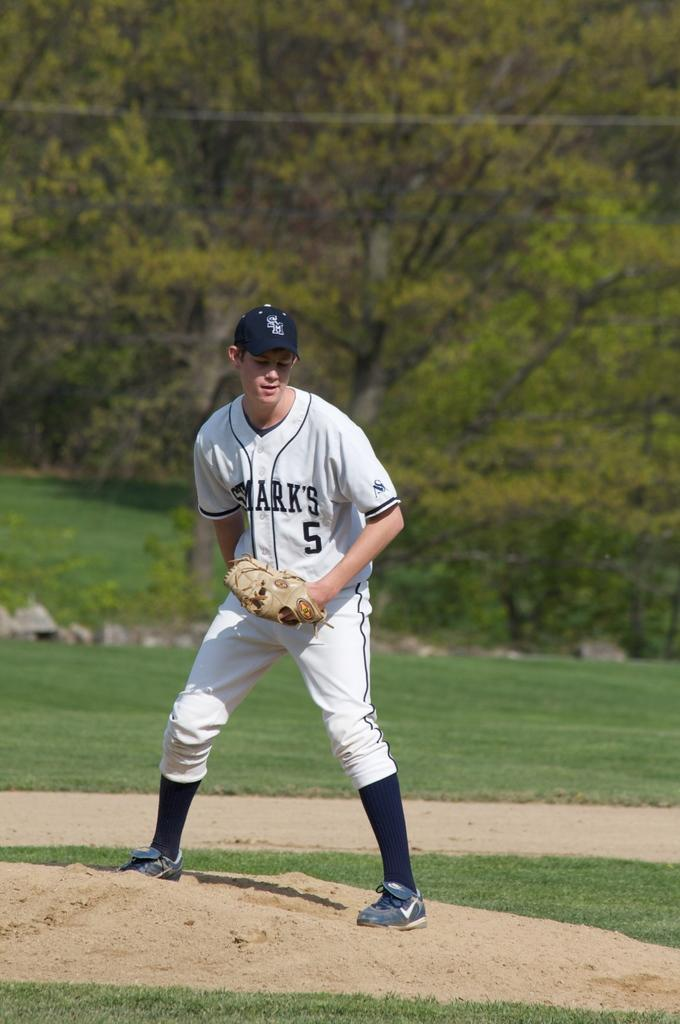<image>
Relay a brief, clear account of the picture shown. A sports man with a number five on a white top. 